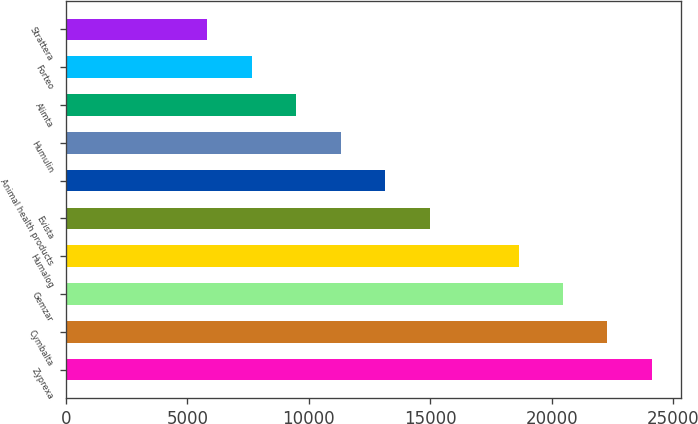Convert chart. <chart><loc_0><loc_0><loc_500><loc_500><bar_chart><fcel>Zyprexa<fcel>Cymbalta<fcel>Gemzar<fcel>Humalog<fcel>Evista<fcel>Animal health products<fcel>Humulin<fcel>Alimta<fcel>Forteo<fcel>Strattera<nl><fcel>24124.3<fcel>22294.1<fcel>20463.8<fcel>18633.5<fcel>14972.9<fcel>13142.7<fcel>11312.4<fcel>9482.1<fcel>7651.82<fcel>5821.54<nl></chart> 